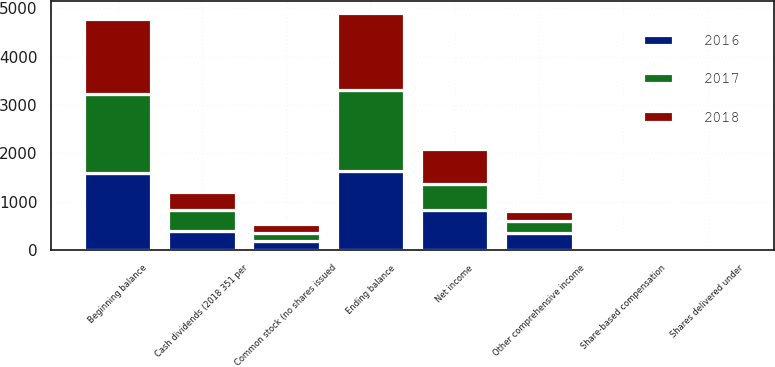Convert chart to OTSL. <chart><loc_0><loc_0><loc_500><loc_500><stacked_bar_chart><ecel><fcel>Common stock (no shares issued<fcel>Beginning balance<fcel>Share-based compensation<fcel>Shares delivered under<fcel>Ending balance<fcel>Net income<fcel>Cash dividends (2018 351 per<fcel>Other comprehensive income<nl><fcel>2017<fcel>181.4<fcel>1638<fcel>37.3<fcel>6.1<fcel>1681.4<fcel>535.5<fcel>440.8<fcel>237.3<nl><fcel>2016<fcel>181.4<fcel>1588.2<fcel>37.4<fcel>12.4<fcel>1638<fcel>825.7<fcel>390.7<fcel>359.6<nl><fcel>2018<fcel>181.4<fcel>1552.1<fcel>39.5<fcel>6.7<fcel>1588.2<fcel>729.7<fcel>378.2<fcel>204.2<nl></chart> 